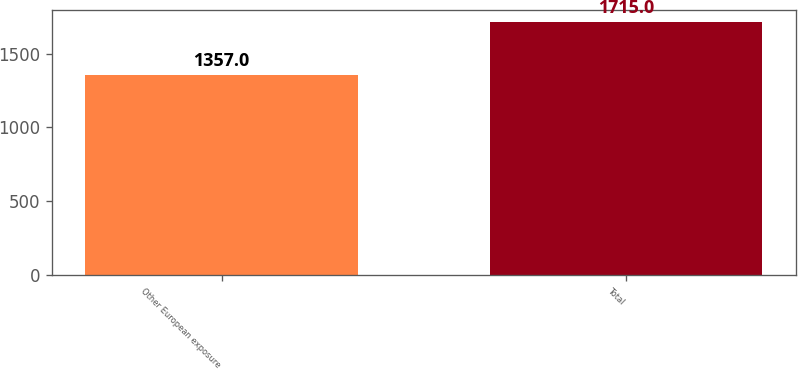<chart> <loc_0><loc_0><loc_500><loc_500><bar_chart><fcel>Other European exposure<fcel>Total<nl><fcel>1357<fcel>1715<nl></chart> 